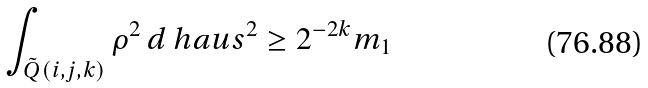<formula> <loc_0><loc_0><loc_500><loc_500>\int _ { \tilde { Q } ( i , j , k ) } \rho ^ { 2 } \, d \ h a u s ^ { 2 } \geq 2 ^ { - 2 k } m _ { 1 }</formula> 